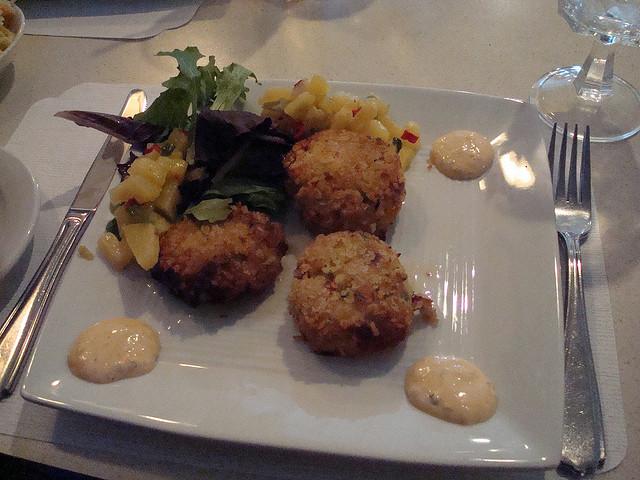How many globs of sauce are visible?
Short answer required. 3. How many spots of sauce are on the plate?
Answer briefly. 3. Where is the fork?
Short answer required. Right. 